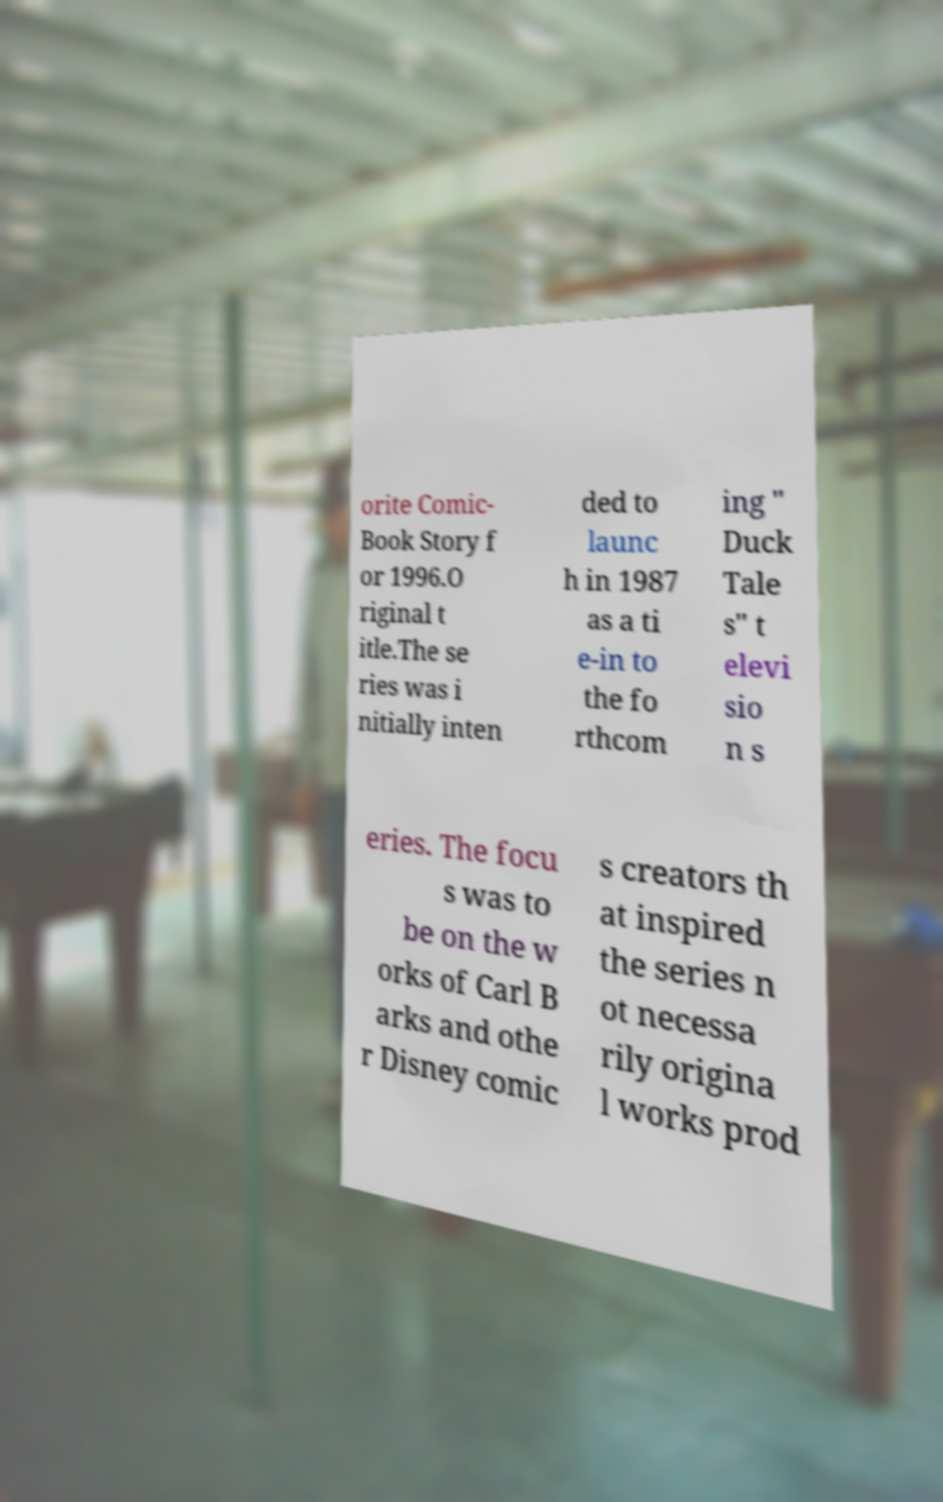Could you assist in decoding the text presented in this image and type it out clearly? orite Comic- Book Story f or 1996.O riginal t itle.The se ries was i nitially inten ded to launc h in 1987 as a ti e-in to the fo rthcom ing " Duck Tale s" t elevi sio n s eries. The focu s was to be on the w orks of Carl B arks and othe r Disney comic s creators th at inspired the series n ot necessa rily origina l works prod 